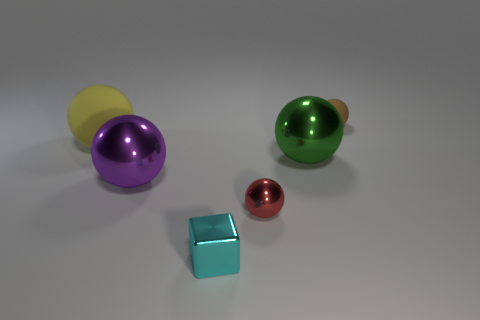Subtract all brown balls. How many balls are left? 4 Subtract all purple spheres. How many spheres are left? 4 Subtract all gray balls. Subtract all brown blocks. How many balls are left? 5 Add 3 green objects. How many objects exist? 9 Subtract all blocks. How many objects are left? 5 Subtract all red shiny objects. Subtract all large matte balls. How many objects are left? 4 Add 2 red metal spheres. How many red metal spheres are left? 3 Add 2 small balls. How many small balls exist? 4 Subtract 0 purple cylinders. How many objects are left? 6 